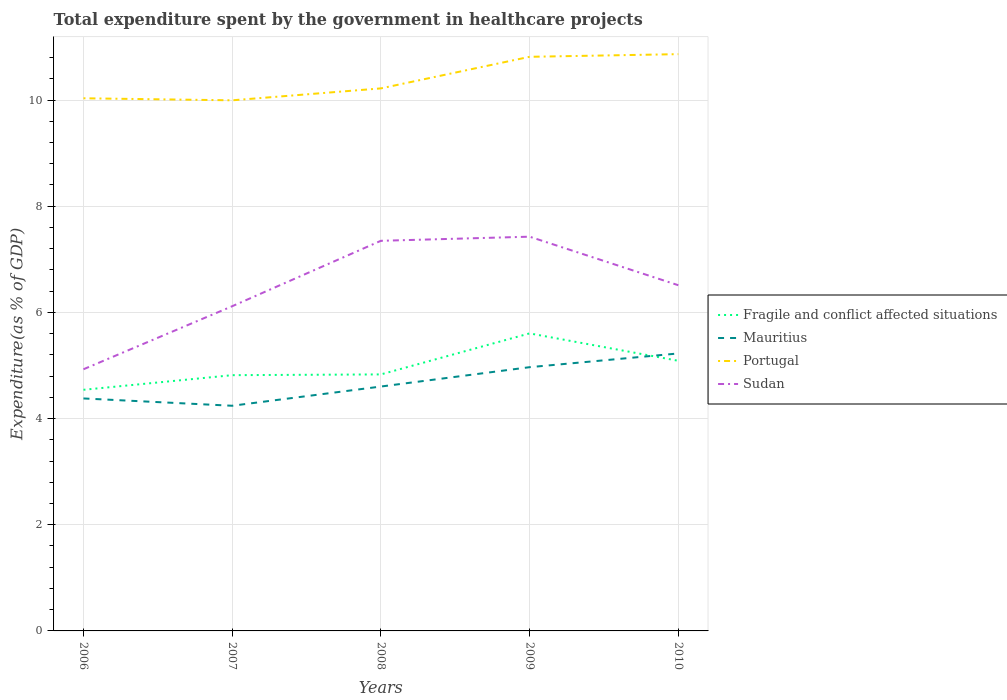How many different coloured lines are there?
Keep it short and to the point. 4. Does the line corresponding to Fragile and conflict affected situations intersect with the line corresponding to Mauritius?
Offer a very short reply. Yes. Across all years, what is the maximum total expenditure spent by the government in healthcare projects in Portugal?
Offer a terse response. 9.99. In which year was the total expenditure spent by the government in healthcare projects in Fragile and conflict affected situations maximum?
Provide a short and direct response. 2006. What is the total total expenditure spent by the government in healthcare projects in Mauritius in the graph?
Make the answer very short. -0.85. What is the difference between the highest and the second highest total expenditure spent by the government in healthcare projects in Portugal?
Your answer should be compact. 0.87. How many lines are there?
Your answer should be compact. 4. How many years are there in the graph?
Give a very brief answer. 5. Are the values on the major ticks of Y-axis written in scientific E-notation?
Offer a terse response. No. Does the graph contain grids?
Keep it short and to the point. Yes. What is the title of the graph?
Provide a succinct answer. Total expenditure spent by the government in healthcare projects. What is the label or title of the X-axis?
Your answer should be very brief. Years. What is the label or title of the Y-axis?
Provide a succinct answer. Expenditure(as % of GDP). What is the Expenditure(as % of GDP) of Fragile and conflict affected situations in 2006?
Make the answer very short. 4.54. What is the Expenditure(as % of GDP) of Mauritius in 2006?
Make the answer very short. 4.38. What is the Expenditure(as % of GDP) in Portugal in 2006?
Ensure brevity in your answer.  10.03. What is the Expenditure(as % of GDP) of Sudan in 2006?
Provide a short and direct response. 4.93. What is the Expenditure(as % of GDP) of Fragile and conflict affected situations in 2007?
Offer a very short reply. 4.82. What is the Expenditure(as % of GDP) in Mauritius in 2007?
Your answer should be compact. 4.24. What is the Expenditure(as % of GDP) in Portugal in 2007?
Your response must be concise. 9.99. What is the Expenditure(as % of GDP) of Sudan in 2007?
Your answer should be very brief. 6.12. What is the Expenditure(as % of GDP) of Fragile and conflict affected situations in 2008?
Provide a short and direct response. 4.83. What is the Expenditure(as % of GDP) of Mauritius in 2008?
Your answer should be compact. 4.6. What is the Expenditure(as % of GDP) in Portugal in 2008?
Ensure brevity in your answer.  10.22. What is the Expenditure(as % of GDP) in Sudan in 2008?
Your answer should be compact. 7.35. What is the Expenditure(as % of GDP) of Fragile and conflict affected situations in 2009?
Make the answer very short. 5.6. What is the Expenditure(as % of GDP) in Mauritius in 2009?
Provide a succinct answer. 4.97. What is the Expenditure(as % of GDP) of Portugal in 2009?
Your response must be concise. 10.81. What is the Expenditure(as % of GDP) in Sudan in 2009?
Give a very brief answer. 7.43. What is the Expenditure(as % of GDP) in Fragile and conflict affected situations in 2010?
Provide a short and direct response. 5.09. What is the Expenditure(as % of GDP) of Mauritius in 2010?
Your answer should be compact. 5.23. What is the Expenditure(as % of GDP) in Portugal in 2010?
Offer a very short reply. 10.86. What is the Expenditure(as % of GDP) in Sudan in 2010?
Provide a short and direct response. 6.51. Across all years, what is the maximum Expenditure(as % of GDP) in Fragile and conflict affected situations?
Give a very brief answer. 5.6. Across all years, what is the maximum Expenditure(as % of GDP) in Mauritius?
Offer a very short reply. 5.23. Across all years, what is the maximum Expenditure(as % of GDP) in Portugal?
Your answer should be very brief. 10.86. Across all years, what is the maximum Expenditure(as % of GDP) in Sudan?
Your response must be concise. 7.43. Across all years, what is the minimum Expenditure(as % of GDP) of Fragile and conflict affected situations?
Give a very brief answer. 4.54. Across all years, what is the minimum Expenditure(as % of GDP) in Mauritius?
Ensure brevity in your answer.  4.24. Across all years, what is the minimum Expenditure(as % of GDP) of Portugal?
Offer a very short reply. 9.99. Across all years, what is the minimum Expenditure(as % of GDP) of Sudan?
Offer a terse response. 4.93. What is the total Expenditure(as % of GDP) of Fragile and conflict affected situations in the graph?
Your answer should be compact. 24.88. What is the total Expenditure(as % of GDP) in Mauritius in the graph?
Your answer should be very brief. 23.42. What is the total Expenditure(as % of GDP) of Portugal in the graph?
Make the answer very short. 51.92. What is the total Expenditure(as % of GDP) in Sudan in the graph?
Keep it short and to the point. 32.33. What is the difference between the Expenditure(as % of GDP) of Fragile and conflict affected situations in 2006 and that in 2007?
Make the answer very short. -0.28. What is the difference between the Expenditure(as % of GDP) in Mauritius in 2006 and that in 2007?
Make the answer very short. 0.14. What is the difference between the Expenditure(as % of GDP) in Portugal in 2006 and that in 2007?
Offer a terse response. 0.04. What is the difference between the Expenditure(as % of GDP) in Sudan in 2006 and that in 2007?
Provide a succinct answer. -1.19. What is the difference between the Expenditure(as % of GDP) in Fragile and conflict affected situations in 2006 and that in 2008?
Your answer should be compact. -0.29. What is the difference between the Expenditure(as % of GDP) in Mauritius in 2006 and that in 2008?
Provide a short and direct response. -0.22. What is the difference between the Expenditure(as % of GDP) of Portugal in 2006 and that in 2008?
Offer a terse response. -0.19. What is the difference between the Expenditure(as % of GDP) in Sudan in 2006 and that in 2008?
Keep it short and to the point. -2.42. What is the difference between the Expenditure(as % of GDP) of Fragile and conflict affected situations in 2006 and that in 2009?
Your response must be concise. -1.06. What is the difference between the Expenditure(as % of GDP) in Mauritius in 2006 and that in 2009?
Your response must be concise. -0.59. What is the difference between the Expenditure(as % of GDP) in Portugal in 2006 and that in 2009?
Make the answer very short. -0.78. What is the difference between the Expenditure(as % of GDP) in Sudan in 2006 and that in 2009?
Your response must be concise. -2.5. What is the difference between the Expenditure(as % of GDP) in Fragile and conflict affected situations in 2006 and that in 2010?
Offer a very short reply. -0.55. What is the difference between the Expenditure(as % of GDP) in Mauritius in 2006 and that in 2010?
Provide a short and direct response. -0.85. What is the difference between the Expenditure(as % of GDP) in Portugal in 2006 and that in 2010?
Ensure brevity in your answer.  -0.83. What is the difference between the Expenditure(as % of GDP) of Sudan in 2006 and that in 2010?
Provide a short and direct response. -1.58. What is the difference between the Expenditure(as % of GDP) in Fragile and conflict affected situations in 2007 and that in 2008?
Your response must be concise. -0.01. What is the difference between the Expenditure(as % of GDP) in Mauritius in 2007 and that in 2008?
Your response must be concise. -0.36. What is the difference between the Expenditure(as % of GDP) in Portugal in 2007 and that in 2008?
Offer a terse response. -0.22. What is the difference between the Expenditure(as % of GDP) of Sudan in 2007 and that in 2008?
Keep it short and to the point. -1.23. What is the difference between the Expenditure(as % of GDP) in Fragile and conflict affected situations in 2007 and that in 2009?
Give a very brief answer. -0.79. What is the difference between the Expenditure(as % of GDP) of Mauritius in 2007 and that in 2009?
Provide a succinct answer. -0.73. What is the difference between the Expenditure(as % of GDP) of Portugal in 2007 and that in 2009?
Ensure brevity in your answer.  -0.82. What is the difference between the Expenditure(as % of GDP) of Sudan in 2007 and that in 2009?
Keep it short and to the point. -1.31. What is the difference between the Expenditure(as % of GDP) of Fragile and conflict affected situations in 2007 and that in 2010?
Offer a terse response. -0.27. What is the difference between the Expenditure(as % of GDP) of Mauritius in 2007 and that in 2010?
Offer a very short reply. -0.99. What is the difference between the Expenditure(as % of GDP) in Portugal in 2007 and that in 2010?
Make the answer very short. -0.87. What is the difference between the Expenditure(as % of GDP) of Sudan in 2007 and that in 2010?
Offer a very short reply. -0.4. What is the difference between the Expenditure(as % of GDP) of Fragile and conflict affected situations in 2008 and that in 2009?
Offer a terse response. -0.77. What is the difference between the Expenditure(as % of GDP) in Mauritius in 2008 and that in 2009?
Give a very brief answer. -0.36. What is the difference between the Expenditure(as % of GDP) of Portugal in 2008 and that in 2009?
Your answer should be very brief. -0.59. What is the difference between the Expenditure(as % of GDP) of Sudan in 2008 and that in 2009?
Keep it short and to the point. -0.08. What is the difference between the Expenditure(as % of GDP) in Fragile and conflict affected situations in 2008 and that in 2010?
Your answer should be very brief. -0.26. What is the difference between the Expenditure(as % of GDP) of Mauritius in 2008 and that in 2010?
Provide a succinct answer. -0.62. What is the difference between the Expenditure(as % of GDP) in Portugal in 2008 and that in 2010?
Ensure brevity in your answer.  -0.64. What is the difference between the Expenditure(as % of GDP) of Sudan in 2008 and that in 2010?
Offer a terse response. 0.84. What is the difference between the Expenditure(as % of GDP) in Fragile and conflict affected situations in 2009 and that in 2010?
Ensure brevity in your answer.  0.52. What is the difference between the Expenditure(as % of GDP) of Mauritius in 2009 and that in 2010?
Offer a terse response. -0.26. What is the difference between the Expenditure(as % of GDP) of Portugal in 2009 and that in 2010?
Your answer should be compact. -0.05. What is the difference between the Expenditure(as % of GDP) in Sudan in 2009 and that in 2010?
Make the answer very short. 0.91. What is the difference between the Expenditure(as % of GDP) in Fragile and conflict affected situations in 2006 and the Expenditure(as % of GDP) in Mauritius in 2007?
Offer a terse response. 0.3. What is the difference between the Expenditure(as % of GDP) in Fragile and conflict affected situations in 2006 and the Expenditure(as % of GDP) in Portugal in 2007?
Offer a very short reply. -5.45. What is the difference between the Expenditure(as % of GDP) of Fragile and conflict affected situations in 2006 and the Expenditure(as % of GDP) of Sudan in 2007?
Offer a very short reply. -1.57. What is the difference between the Expenditure(as % of GDP) in Mauritius in 2006 and the Expenditure(as % of GDP) in Portugal in 2007?
Your answer should be compact. -5.62. What is the difference between the Expenditure(as % of GDP) in Mauritius in 2006 and the Expenditure(as % of GDP) in Sudan in 2007?
Make the answer very short. -1.74. What is the difference between the Expenditure(as % of GDP) of Portugal in 2006 and the Expenditure(as % of GDP) of Sudan in 2007?
Ensure brevity in your answer.  3.92. What is the difference between the Expenditure(as % of GDP) in Fragile and conflict affected situations in 2006 and the Expenditure(as % of GDP) in Mauritius in 2008?
Make the answer very short. -0.06. What is the difference between the Expenditure(as % of GDP) of Fragile and conflict affected situations in 2006 and the Expenditure(as % of GDP) of Portugal in 2008?
Make the answer very short. -5.68. What is the difference between the Expenditure(as % of GDP) in Fragile and conflict affected situations in 2006 and the Expenditure(as % of GDP) in Sudan in 2008?
Your answer should be very brief. -2.81. What is the difference between the Expenditure(as % of GDP) of Mauritius in 2006 and the Expenditure(as % of GDP) of Portugal in 2008?
Provide a succinct answer. -5.84. What is the difference between the Expenditure(as % of GDP) in Mauritius in 2006 and the Expenditure(as % of GDP) in Sudan in 2008?
Ensure brevity in your answer.  -2.97. What is the difference between the Expenditure(as % of GDP) of Portugal in 2006 and the Expenditure(as % of GDP) of Sudan in 2008?
Provide a succinct answer. 2.68. What is the difference between the Expenditure(as % of GDP) of Fragile and conflict affected situations in 2006 and the Expenditure(as % of GDP) of Mauritius in 2009?
Keep it short and to the point. -0.43. What is the difference between the Expenditure(as % of GDP) in Fragile and conflict affected situations in 2006 and the Expenditure(as % of GDP) in Portugal in 2009?
Your response must be concise. -6.27. What is the difference between the Expenditure(as % of GDP) in Fragile and conflict affected situations in 2006 and the Expenditure(as % of GDP) in Sudan in 2009?
Give a very brief answer. -2.88. What is the difference between the Expenditure(as % of GDP) of Mauritius in 2006 and the Expenditure(as % of GDP) of Portugal in 2009?
Offer a terse response. -6.43. What is the difference between the Expenditure(as % of GDP) in Mauritius in 2006 and the Expenditure(as % of GDP) in Sudan in 2009?
Give a very brief answer. -3.05. What is the difference between the Expenditure(as % of GDP) of Portugal in 2006 and the Expenditure(as % of GDP) of Sudan in 2009?
Your response must be concise. 2.61. What is the difference between the Expenditure(as % of GDP) of Fragile and conflict affected situations in 2006 and the Expenditure(as % of GDP) of Mauritius in 2010?
Your answer should be compact. -0.68. What is the difference between the Expenditure(as % of GDP) in Fragile and conflict affected situations in 2006 and the Expenditure(as % of GDP) in Portugal in 2010?
Provide a short and direct response. -6.32. What is the difference between the Expenditure(as % of GDP) of Fragile and conflict affected situations in 2006 and the Expenditure(as % of GDP) of Sudan in 2010?
Provide a short and direct response. -1.97. What is the difference between the Expenditure(as % of GDP) of Mauritius in 2006 and the Expenditure(as % of GDP) of Portugal in 2010?
Offer a terse response. -6.48. What is the difference between the Expenditure(as % of GDP) in Mauritius in 2006 and the Expenditure(as % of GDP) in Sudan in 2010?
Provide a succinct answer. -2.13. What is the difference between the Expenditure(as % of GDP) in Portugal in 2006 and the Expenditure(as % of GDP) in Sudan in 2010?
Your answer should be very brief. 3.52. What is the difference between the Expenditure(as % of GDP) of Fragile and conflict affected situations in 2007 and the Expenditure(as % of GDP) of Mauritius in 2008?
Make the answer very short. 0.21. What is the difference between the Expenditure(as % of GDP) in Fragile and conflict affected situations in 2007 and the Expenditure(as % of GDP) in Portugal in 2008?
Offer a terse response. -5.4. What is the difference between the Expenditure(as % of GDP) in Fragile and conflict affected situations in 2007 and the Expenditure(as % of GDP) in Sudan in 2008?
Offer a very short reply. -2.53. What is the difference between the Expenditure(as % of GDP) in Mauritius in 2007 and the Expenditure(as % of GDP) in Portugal in 2008?
Provide a short and direct response. -5.98. What is the difference between the Expenditure(as % of GDP) in Mauritius in 2007 and the Expenditure(as % of GDP) in Sudan in 2008?
Offer a very short reply. -3.11. What is the difference between the Expenditure(as % of GDP) of Portugal in 2007 and the Expenditure(as % of GDP) of Sudan in 2008?
Provide a succinct answer. 2.65. What is the difference between the Expenditure(as % of GDP) in Fragile and conflict affected situations in 2007 and the Expenditure(as % of GDP) in Mauritius in 2009?
Give a very brief answer. -0.15. What is the difference between the Expenditure(as % of GDP) of Fragile and conflict affected situations in 2007 and the Expenditure(as % of GDP) of Portugal in 2009?
Your response must be concise. -6. What is the difference between the Expenditure(as % of GDP) of Fragile and conflict affected situations in 2007 and the Expenditure(as % of GDP) of Sudan in 2009?
Make the answer very short. -2.61. What is the difference between the Expenditure(as % of GDP) of Mauritius in 2007 and the Expenditure(as % of GDP) of Portugal in 2009?
Offer a terse response. -6.57. What is the difference between the Expenditure(as % of GDP) in Mauritius in 2007 and the Expenditure(as % of GDP) in Sudan in 2009?
Provide a succinct answer. -3.18. What is the difference between the Expenditure(as % of GDP) in Portugal in 2007 and the Expenditure(as % of GDP) in Sudan in 2009?
Provide a short and direct response. 2.57. What is the difference between the Expenditure(as % of GDP) of Fragile and conflict affected situations in 2007 and the Expenditure(as % of GDP) of Mauritius in 2010?
Keep it short and to the point. -0.41. What is the difference between the Expenditure(as % of GDP) of Fragile and conflict affected situations in 2007 and the Expenditure(as % of GDP) of Portugal in 2010?
Offer a terse response. -6.05. What is the difference between the Expenditure(as % of GDP) in Fragile and conflict affected situations in 2007 and the Expenditure(as % of GDP) in Sudan in 2010?
Make the answer very short. -1.69. What is the difference between the Expenditure(as % of GDP) of Mauritius in 2007 and the Expenditure(as % of GDP) of Portugal in 2010?
Offer a very short reply. -6.62. What is the difference between the Expenditure(as % of GDP) in Mauritius in 2007 and the Expenditure(as % of GDP) in Sudan in 2010?
Offer a terse response. -2.27. What is the difference between the Expenditure(as % of GDP) in Portugal in 2007 and the Expenditure(as % of GDP) in Sudan in 2010?
Provide a short and direct response. 3.48. What is the difference between the Expenditure(as % of GDP) in Fragile and conflict affected situations in 2008 and the Expenditure(as % of GDP) in Mauritius in 2009?
Your answer should be very brief. -0.14. What is the difference between the Expenditure(as % of GDP) in Fragile and conflict affected situations in 2008 and the Expenditure(as % of GDP) in Portugal in 2009?
Ensure brevity in your answer.  -5.98. What is the difference between the Expenditure(as % of GDP) of Fragile and conflict affected situations in 2008 and the Expenditure(as % of GDP) of Sudan in 2009?
Your answer should be compact. -2.59. What is the difference between the Expenditure(as % of GDP) in Mauritius in 2008 and the Expenditure(as % of GDP) in Portugal in 2009?
Give a very brief answer. -6.21. What is the difference between the Expenditure(as % of GDP) of Mauritius in 2008 and the Expenditure(as % of GDP) of Sudan in 2009?
Give a very brief answer. -2.82. What is the difference between the Expenditure(as % of GDP) in Portugal in 2008 and the Expenditure(as % of GDP) in Sudan in 2009?
Provide a short and direct response. 2.79. What is the difference between the Expenditure(as % of GDP) of Fragile and conflict affected situations in 2008 and the Expenditure(as % of GDP) of Mauritius in 2010?
Ensure brevity in your answer.  -0.39. What is the difference between the Expenditure(as % of GDP) in Fragile and conflict affected situations in 2008 and the Expenditure(as % of GDP) in Portugal in 2010?
Provide a succinct answer. -6.03. What is the difference between the Expenditure(as % of GDP) of Fragile and conflict affected situations in 2008 and the Expenditure(as % of GDP) of Sudan in 2010?
Your answer should be very brief. -1.68. What is the difference between the Expenditure(as % of GDP) of Mauritius in 2008 and the Expenditure(as % of GDP) of Portugal in 2010?
Your response must be concise. -6.26. What is the difference between the Expenditure(as % of GDP) in Mauritius in 2008 and the Expenditure(as % of GDP) in Sudan in 2010?
Offer a terse response. -1.91. What is the difference between the Expenditure(as % of GDP) in Portugal in 2008 and the Expenditure(as % of GDP) in Sudan in 2010?
Provide a succinct answer. 3.71. What is the difference between the Expenditure(as % of GDP) in Fragile and conflict affected situations in 2009 and the Expenditure(as % of GDP) in Mauritius in 2010?
Your response must be concise. 0.38. What is the difference between the Expenditure(as % of GDP) in Fragile and conflict affected situations in 2009 and the Expenditure(as % of GDP) in Portugal in 2010?
Your answer should be compact. -5.26. What is the difference between the Expenditure(as % of GDP) in Fragile and conflict affected situations in 2009 and the Expenditure(as % of GDP) in Sudan in 2010?
Keep it short and to the point. -0.91. What is the difference between the Expenditure(as % of GDP) in Mauritius in 2009 and the Expenditure(as % of GDP) in Portugal in 2010?
Offer a very short reply. -5.9. What is the difference between the Expenditure(as % of GDP) of Mauritius in 2009 and the Expenditure(as % of GDP) of Sudan in 2010?
Your answer should be compact. -1.54. What is the difference between the Expenditure(as % of GDP) of Portugal in 2009 and the Expenditure(as % of GDP) of Sudan in 2010?
Offer a very short reply. 4.3. What is the average Expenditure(as % of GDP) of Fragile and conflict affected situations per year?
Give a very brief answer. 4.98. What is the average Expenditure(as % of GDP) in Mauritius per year?
Your answer should be very brief. 4.68. What is the average Expenditure(as % of GDP) of Portugal per year?
Your answer should be compact. 10.38. What is the average Expenditure(as % of GDP) of Sudan per year?
Give a very brief answer. 6.47. In the year 2006, what is the difference between the Expenditure(as % of GDP) of Fragile and conflict affected situations and Expenditure(as % of GDP) of Mauritius?
Provide a short and direct response. 0.16. In the year 2006, what is the difference between the Expenditure(as % of GDP) of Fragile and conflict affected situations and Expenditure(as % of GDP) of Portugal?
Your answer should be very brief. -5.49. In the year 2006, what is the difference between the Expenditure(as % of GDP) in Fragile and conflict affected situations and Expenditure(as % of GDP) in Sudan?
Keep it short and to the point. -0.39. In the year 2006, what is the difference between the Expenditure(as % of GDP) in Mauritius and Expenditure(as % of GDP) in Portugal?
Provide a succinct answer. -5.65. In the year 2006, what is the difference between the Expenditure(as % of GDP) in Mauritius and Expenditure(as % of GDP) in Sudan?
Give a very brief answer. -0.55. In the year 2006, what is the difference between the Expenditure(as % of GDP) in Portugal and Expenditure(as % of GDP) in Sudan?
Offer a very short reply. 5.1. In the year 2007, what is the difference between the Expenditure(as % of GDP) of Fragile and conflict affected situations and Expenditure(as % of GDP) of Mauritius?
Your response must be concise. 0.58. In the year 2007, what is the difference between the Expenditure(as % of GDP) in Fragile and conflict affected situations and Expenditure(as % of GDP) in Portugal?
Provide a succinct answer. -5.18. In the year 2007, what is the difference between the Expenditure(as % of GDP) of Fragile and conflict affected situations and Expenditure(as % of GDP) of Sudan?
Keep it short and to the point. -1.3. In the year 2007, what is the difference between the Expenditure(as % of GDP) in Mauritius and Expenditure(as % of GDP) in Portugal?
Offer a terse response. -5.75. In the year 2007, what is the difference between the Expenditure(as % of GDP) of Mauritius and Expenditure(as % of GDP) of Sudan?
Your answer should be compact. -1.87. In the year 2007, what is the difference between the Expenditure(as % of GDP) in Portugal and Expenditure(as % of GDP) in Sudan?
Provide a succinct answer. 3.88. In the year 2008, what is the difference between the Expenditure(as % of GDP) of Fragile and conflict affected situations and Expenditure(as % of GDP) of Mauritius?
Your response must be concise. 0.23. In the year 2008, what is the difference between the Expenditure(as % of GDP) in Fragile and conflict affected situations and Expenditure(as % of GDP) in Portugal?
Give a very brief answer. -5.39. In the year 2008, what is the difference between the Expenditure(as % of GDP) of Fragile and conflict affected situations and Expenditure(as % of GDP) of Sudan?
Provide a short and direct response. -2.52. In the year 2008, what is the difference between the Expenditure(as % of GDP) in Mauritius and Expenditure(as % of GDP) in Portugal?
Make the answer very short. -5.62. In the year 2008, what is the difference between the Expenditure(as % of GDP) in Mauritius and Expenditure(as % of GDP) in Sudan?
Your answer should be very brief. -2.75. In the year 2008, what is the difference between the Expenditure(as % of GDP) of Portugal and Expenditure(as % of GDP) of Sudan?
Keep it short and to the point. 2.87. In the year 2009, what is the difference between the Expenditure(as % of GDP) of Fragile and conflict affected situations and Expenditure(as % of GDP) of Mauritius?
Offer a terse response. 0.64. In the year 2009, what is the difference between the Expenditure(as % of GDP) of Fragile and conflict affected situations and Expenditure(as % of GDP) of Portugal?
Ensure brevity in your answer.  -5.21. In the year 2009, what is the difference between the Expenditure(as % of GDP) in Fragile and conflict affected situations and Expenditure(as % of GDP) in Sudan?
Your answer should be compact. -1.82. In the year 2009, what is the difference between the Expenditure(as % of GDP) in Mauritius and Expenditure(as % of GDP) in Portugal?
Your answer should be compact. -5.85. In the year 2009, what is the difference between the Expenditure(as % of GDP) in Mauritius and Expenditure(as % of GDP) in Sudan?
Keep it short and to the point. -2.46. In the year 2009, what is the difference between the Expenditure(as % of GDP) in Portugal and Expenditure(as % of GDP) in Sudan?
Make the answer very short. 3.39. In the year 2010, what is the difference between the Expenditure(as % of GDP) of Fragile and conflict affected situations and Expenditure(as % of GDP) of Mauritius?
Provide a short and direct response. -0.14. In the year 2010, what is the difference between the Expenditure(as % of GDP) in Fragile and conflict affected situations and Expenditure(as % of GDP) in Portugal?
Your answer should be compact. -5.78. In the year 2010, what is the difference between the Expenditure(as % of GDP) in Fragile and conflict affected situations and Expenditure(as % of GDP) in Sudan?
Offer a terse response. -1.42. In the year 2010, what is the difference between the Expenditure(as % of GDP) of Mauritius and Expenditure(as % of GDP) of Portugal?
Offer a very short reply. -5.64. In the year 2010, what is the difference between the Expenditure(as % of GDP) of Mauritius and Expenditure(as % of GDP) of Sudan?
Offer a very short reply. -1.28. In the year 2010, what is the difference between the Expenditure(as % of GDP) of Portugal and Expenditure(as % of GDP) of Sudan?
Ensure brevity in your answer.  4.35. What is the ratio of the Expenditure(as % of GDP) in Fragile and conflict affected situations in 2006 to that in 2007?
Provide a succinct answer. 0.94. What is the ratio of the Expenditure(as % of GDP) in Mauritius in 2006 to that in 2007?
Provide a short and direct response. 1.03. What is the ratio of the Expenditure(as % of GDP) in Sudan in 2006 to that in 2007?
Your answer should be compact. 0.81. What is the ratio of the Expenditure(as % of GDP) of Mauritius in 2006 to that in 2008?
Your answer should be very brief. 0.95. What is the ratio of the Expenditure(as % of GDP) in Portugal in 2006 to that in 2008?
Offer a very short reply. 0.98. What is the ratio of the Expenditure(as % of GDP) in Sudan in 2006 to that in 2008?
Provide a short and direct response. 0.67. What is the ratio of the Expenditure(as % of GDP) of Fragile and conflict affected situations in 2006 to that in 2009?
Make the answer very short. 0.81. What is the ratio of the Expenditure(as % of GDP) in Mauritius in 2006 to that in 2009?
Offer a terse response. 0.88. What is the ratio of the Expenditure(as % of GDP) in Portugal in 2006 to that in 2009?
Ensure brevity in your answer.  0.93. What is the ratio of the Expenditure(as % of GDP) of Sudan in 2006 to that in 2009?
Provide a short and direct response. 0.66. What is the ratio of the Expenditure(as % of GDP) in Fragile and conflict affected situations in 2006 to that in 2010?
Your answer should be very brief. 0.89. What is the ratio of the Expenditure(as % of GDP) in Mauritius in 2006 to that in 2010?
Offer a very short reply. 0.84. What is the ratio of the Expenditure(as % of GDP) in Portugal in 2006 to that in 2010?
Keep it short and to the point. 0.92. What is the ratio of the Expenditure(as % of GDP) of Sudan in 2006 to that in 2010?
Provide a succinct answer. 0.76. What is the ratio of the Expenditure(as % of GDP) in Fragile and conflict affected situations in 2007 to that in 2008?
Your answer should be very brief. 1. What is the ratio of the Expenditure(as % of GDP) of Mauritius in 2007 to that in 2008?
Your answer should be compact. 0.92. What is the ratio of the Expenditure(as % of GDP) of Sudan in 2007 to that in 2008?
Give a very brief answer. 0.83. What is the ratio of the Expenditure(as % of GDP) in Fragile and conflict affected situations in 2007 to that in 2009?
Give a very brief answer. 0.86. What is the ratio of the Expenditure(as % of GDP) in Mauritius in 2007 to that in 2009?
Offer a very short reply. 0.85. What is the ratio of the Expenditure(as % of GDP) of Portugal in 2007 to that in 2009?
Your response must be concise. 0.92. What is the ratio of the Expenditure(as % of GDP) in Sudan in 2007 to that in 2009?
Make the answer very short. 0.82. What is the ratio of the Expenditure(as % of GDP) of Fragile and conflict affected situations in 2007 to that in 2010?
Your answer should be very brief. 0.95. What is the ratio of the Expenditure(as % of GDP) of Mauritius in 2007 to that in 2010?
Offer a very short reply. 0.81. What is the ratio of the Expenditure(as % of GDP) of Sudan in 2007 to that in 2010?
Your answer should be very brief. 0.94. What is the ratio of the Expenditure(as % of GDP) of Fragile and conflict affected situations in 2008 to that in 2009?
Provide a short and direct response. 0.86. What is the ratio of the Expenditure(as % of GDP) in Mauritius in 2008 to that in 2009?
Ensure brevity in your answer.  0.93. What is the ratio of the Expenditure(as % of GDP) of Portugal in 2008 to that in 2009?
Offer a terse response. 0.94. What is the ratio of the Expenditure(as % of GDP) in Fragile and conflict affected situations in 2008 to that in 2010?
Your answer should be very brief. 0.95. What is the ratio of the Expenditure(as % of GDP) in Mauritius in 2008 to that in 2010?
Make the answer very short. 0.88. What is the ratio of the Expenditure(as % of GDP) of Portugal in 2008 to that in 2010?
Your answer should be very brief. 0.94. What is the ratio of the Expenditure(as % of GDP) of Sudan in 2008 to that in 2010?
Provide a short and direct response. 1.13. What is the ratio of the Expenditure(as % of GDP) in Fragile and conflict affected situations in 2009 to that in 2010?
Make the answer very short. 1.1. What is the ratio of the Expenditure(as % of GDP) in Mauritius in 2009 to that in 2010?
Make the answer very short. 0.95. What is the ratio of the Expenditure(as % of GDP) of Sudan in 2009 to that in 2010?
Provide a short and direct response. 1.14. What is the difference between the highest and the second highest Expenditure(as % of GDP) of Fragile and conflict affected situations?
Offer a terse response. 0.52. What is the difference between the highest and the second highest Expenditure(as % of GDP) in Mauritius?
Your response must be concise. 0.26. What is the difference between the highest and the second highest Expenditure(as % of GDP) in Portugal?
Your response must be concise. 0.05. What is the difference between the highest and the second highest Expenditure(as % of GDP) of Sudan?
Offer a very short reply. 0.08. What is the difference between the highest and the lowest Expenditure(as % of GDP) in Fragile and conflict affected situations?
Your response must be concise. 1.06. What is the difference between the highest and the lowest Expenditure(as % of GDP) in Mauritius?
Offer a terse response. 0.99. What is the difference between the highest and the lowest Expenditure(as % of GDP) in Portugal?
Ensure brevity in your answer.  0.87. What is the difference between the highest and the lowest Expenditure(as % of GDP) of Sudan?
Provide a succinct answer. 2.5. 